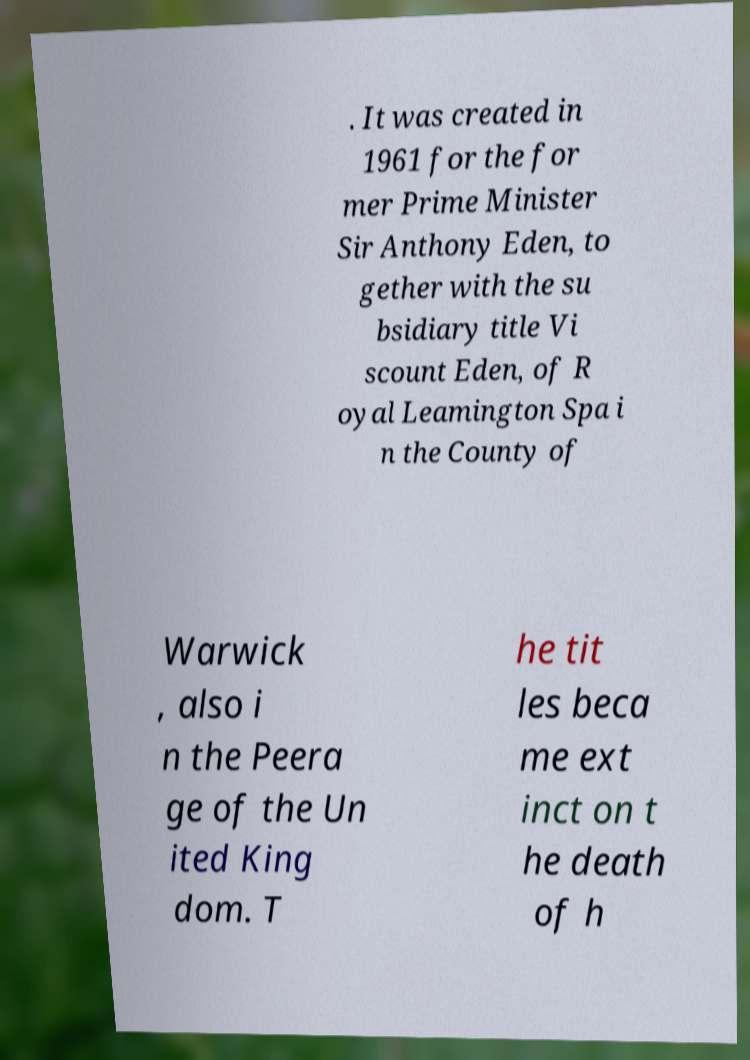I need the written content from this picture converted into text. Can you do that? . It was created in 1961 for the for mer Prime Minister Sir Anthony Eden, to gether with the su bsidiary title Vi scount Eden, of R oyal Leamington Spa i n the County of Warwick , also i n the Peera ge of the Un ited King dom. T he tit les beca me ext inct on t he death of h 